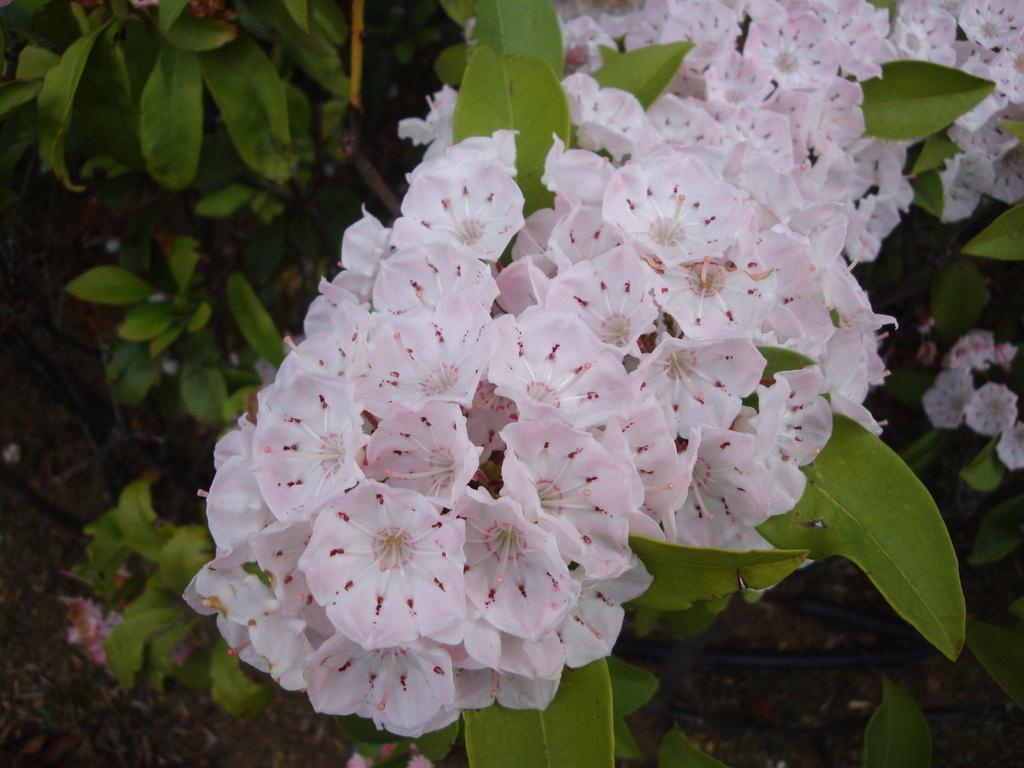What type of living organism is present in the image? There is a plant in the image. What are the main features of the plant? The plant has leaves and flowers. What color are the flowers on the plant? The flowers are white in color. Where is the sponge located in the image? There is no sponge present in the image. What type of alley can be seen in the image? There is no alley present in the image. 